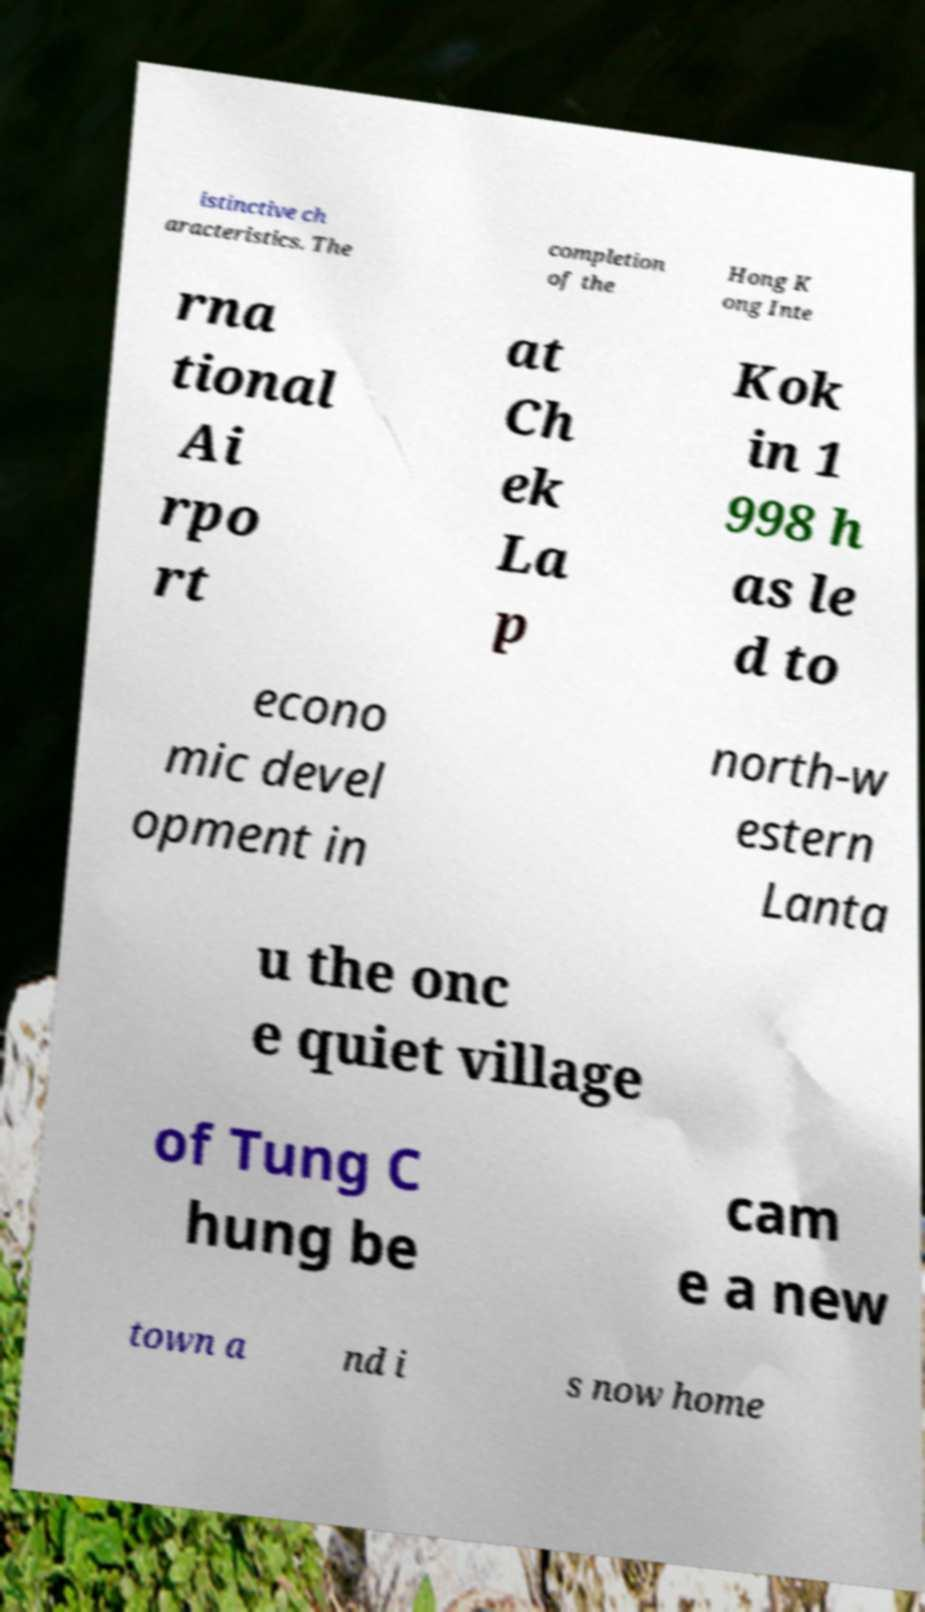Could you extract and type out the text from this image? istinctive ch aracteristics. The completion of the Hong K ong Inte rna tional Ai rpo rt at Ch ek La p Kok in 1 998 h as le d to econo mic devel opment in north-w estern Lanta u the onc e quiet village of Tung C hung be cam e a new town a nd i s now home 